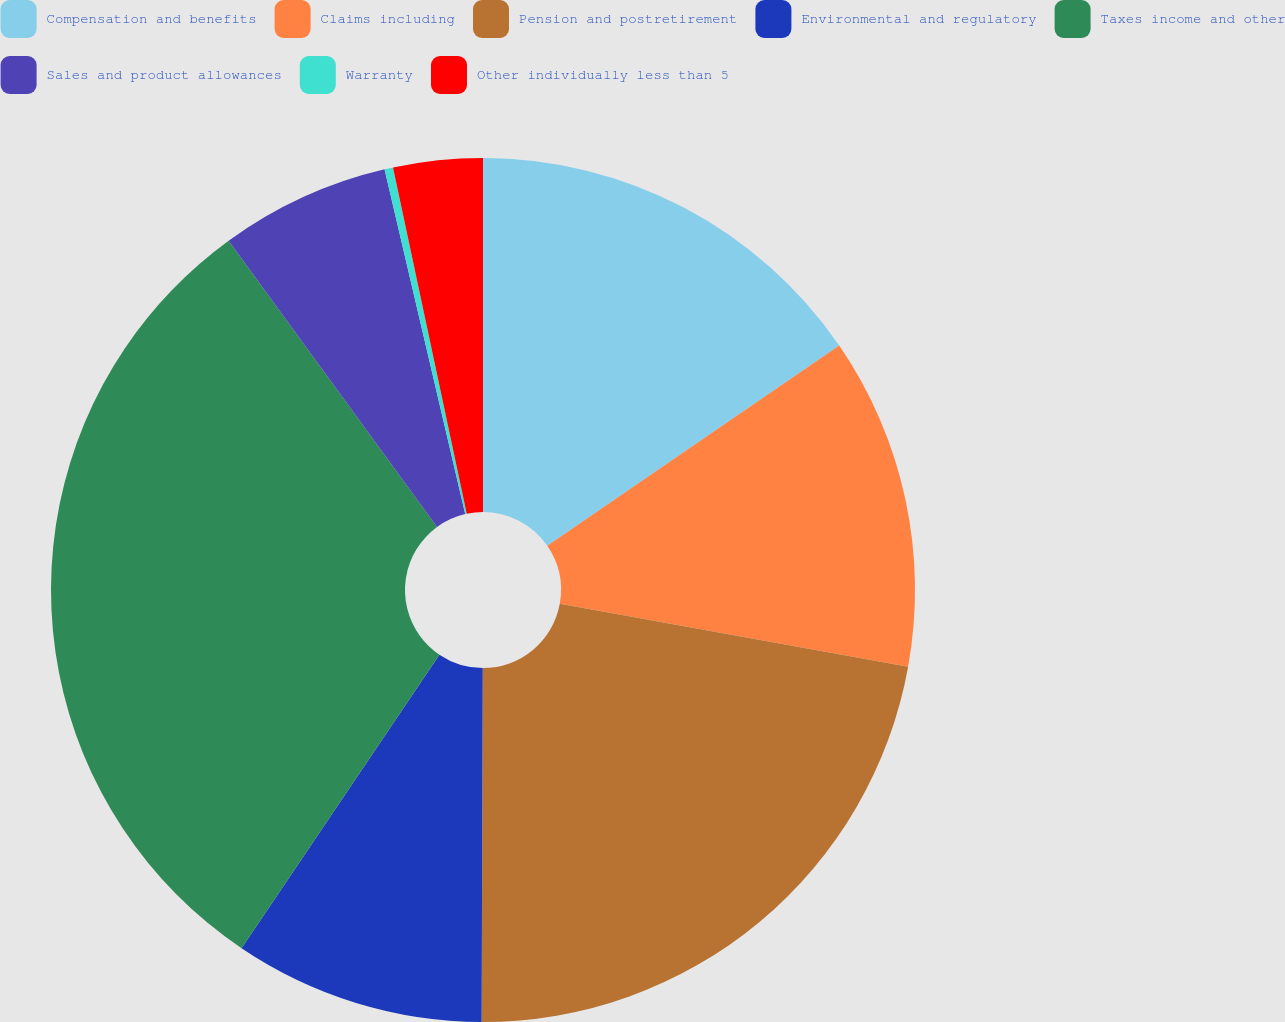<chart> <loc_0><loc_0><loc_500><loc_500><pie_chart><fcel>Compensation and benefits<fcel>Claims including<fcel>Pension and postretirement<fcel>Environmental and regulatory<fcel>Taxes income and other<fcel>Sales and product allowances<fcel>Warranty<fcel>Other individually less than 5<nl><fcel>15.43%<fcel>12.41%<fcel>22.21%<fcel>9.39%<fcel>30.54%<fcel>6.36%<fcel>0.32%<fcel>3.34%<nl></chart> 